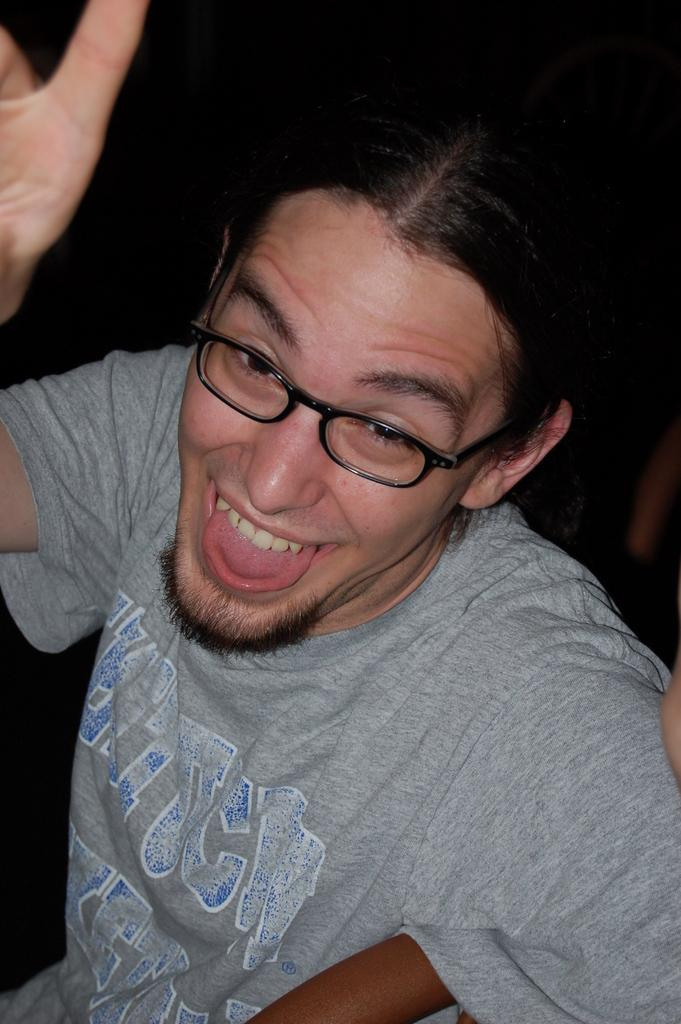Who or what is the main subject of the image? There is a person in the image. What is the person wearing? The person is wearing an ash-colored dress. What can be seen behind the person in the image? The background of the image is black. Can you see any ocean waves in the image? There is no ocean or waves present in the image; it features a person wearing an ash-colored dress against a black background. What type of pancake is the person holding in the image? There is no pancake visible in the image, and the person is not holding anything. 